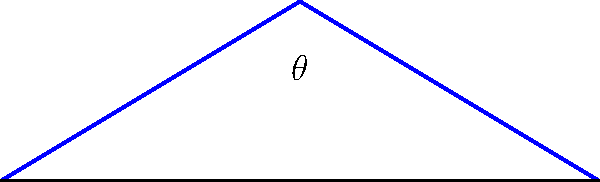As a fitness coach who understands the importance of proper drainage in outdoor training facilities, you're consulting on a new gym construction project. The architect asks for your input on the optimal angle for the sloped roof to maximize drainage efficiency. Given that the roof pitch is determined by the angle $\theta$ between the roof surface and the horizontal, what range of angles would you recommend for optimal drainage, considering both water runoff and structural integrity? To determine the optimal angle for a sloped roof to maximize drainage efficiency, we need to consider several factors:

1. Minimum slope for effective drainage:
   - A minimum slope of 1/4 inch per foot (approximately 1.19 degrees) is generally required for proper drainage.
   - However, this is often considered too shallow for most applications.

2. Standard roof pitches:
   - Typical residential roofs have slopes between 4/12 (18.43 degrees) and 9/12 (36.87 degrees).
   - Steeper slopes provide better drainage but can be more challenging to construct and maintain.

3. Optimal range for drainage:
   - A slope between 30 to 40 degrees is generally considered optimal for drainage efficiency.
   - This range balances good water runoff with practical construction considerations.

4. Structural integrity:
   - Slopes greater than 45 degrees may require additional structural support.
   - Very steep roofs can increase wind loads and construction costs.

5. Local climate considerations:
   - In areas with heavy rainfall or snowfall, steeper slopes (closer to 40 degrees) may be preferable.
   - In milder climates, slopes closer to 30 degrees may be sufficient.

6. Building codes and regulations:
   - Local building codes may specify minimum slopes for different roofing materials.
   - Always consult local regulations when making final decisions.

Considering these factors, a range of 30 to 40 degrees ($\theta = 30^\circ$ to $40^\circ$) provides an optimal balance between drainage efficiency, structural integrity, and practical construction for most applications.
Answer: $30^\circ$ to $40^\circ$ 